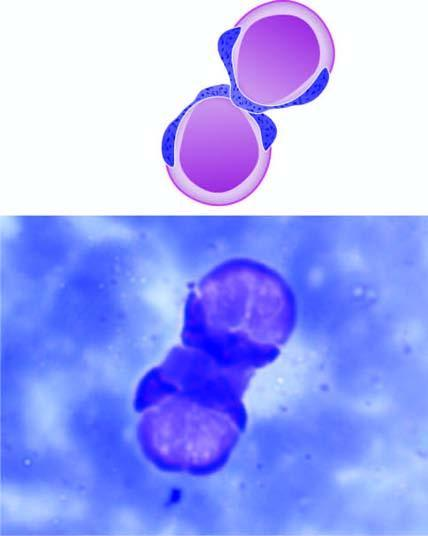what are there having rounded masses of amorphous nuclear material which has displaced the lobes of neutrophil to the rim of the cell?
Answer the question using a single word or phrase. Two cell 